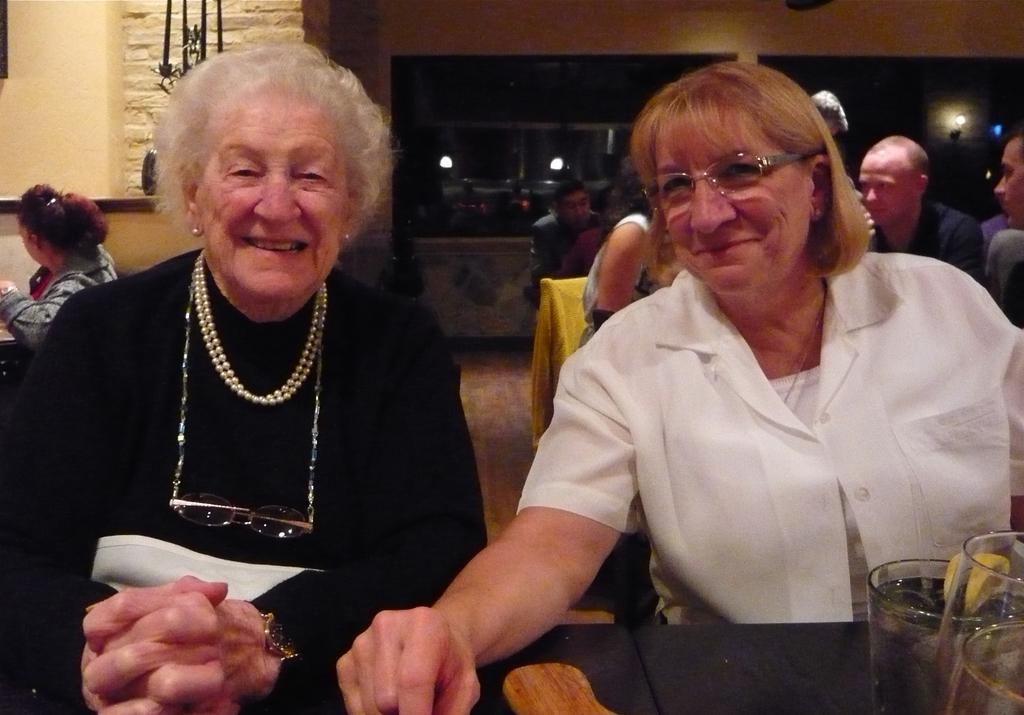Could you give a brief overview of what you see in this image? On the left side, there is a woman in black color dress smiling, sitting and placing both hands on the table. On the right side, there is a woman in white color shirt sitting and placing a hand on the table on which, there are glasses arranged. In the background, there are persons sitting and there is wall. 